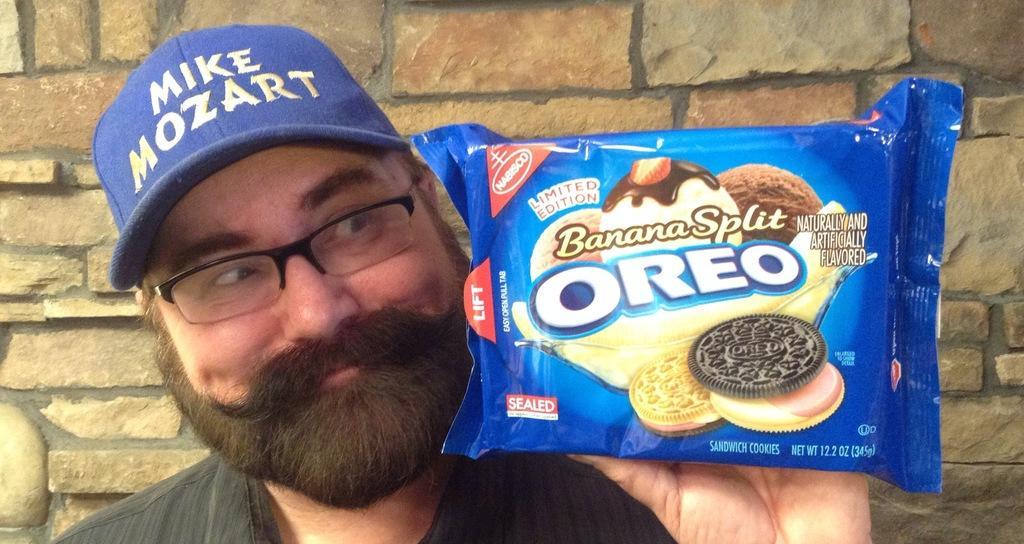How would you summarize this image in a sentence or two? In this image there is one person standing at left side of this image is wearing specs and blue color cap. He is holding a biscuit packet as we can see at right side of this image and there is a wall in the background. 